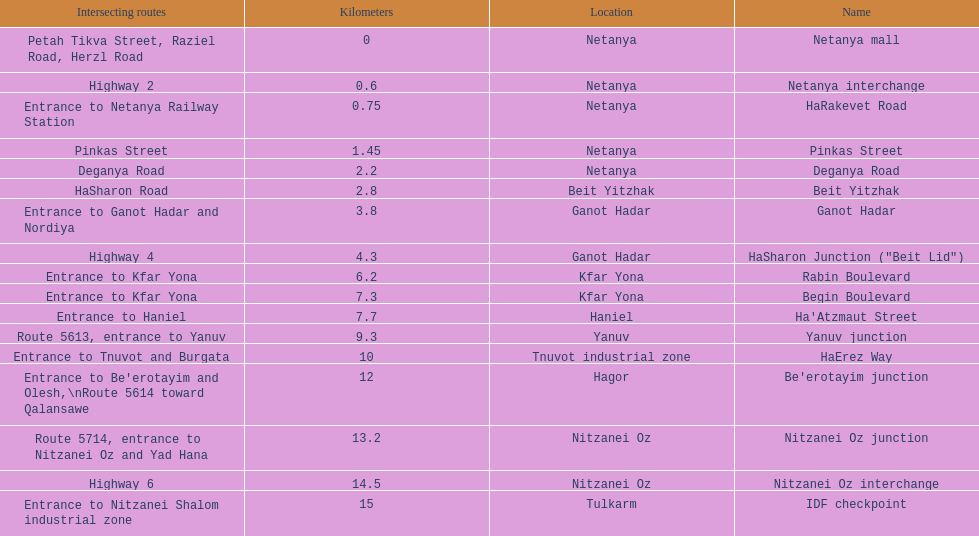After you complete deganya road, what portion comes next? Beit Yitzhak. 